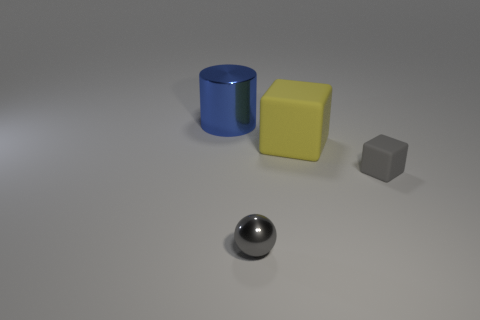How might the arrangement of these objects influence our perception of space in the image? The strategic placement of the objects with adequate space in between them creates a sense of depth and dimension. It suggests a deliberate arrangement meant to emphasize the individuality of each object's geometry and color, effecting a simplistic yet effective demonstration of spatial relations in a minimalistic setting. 